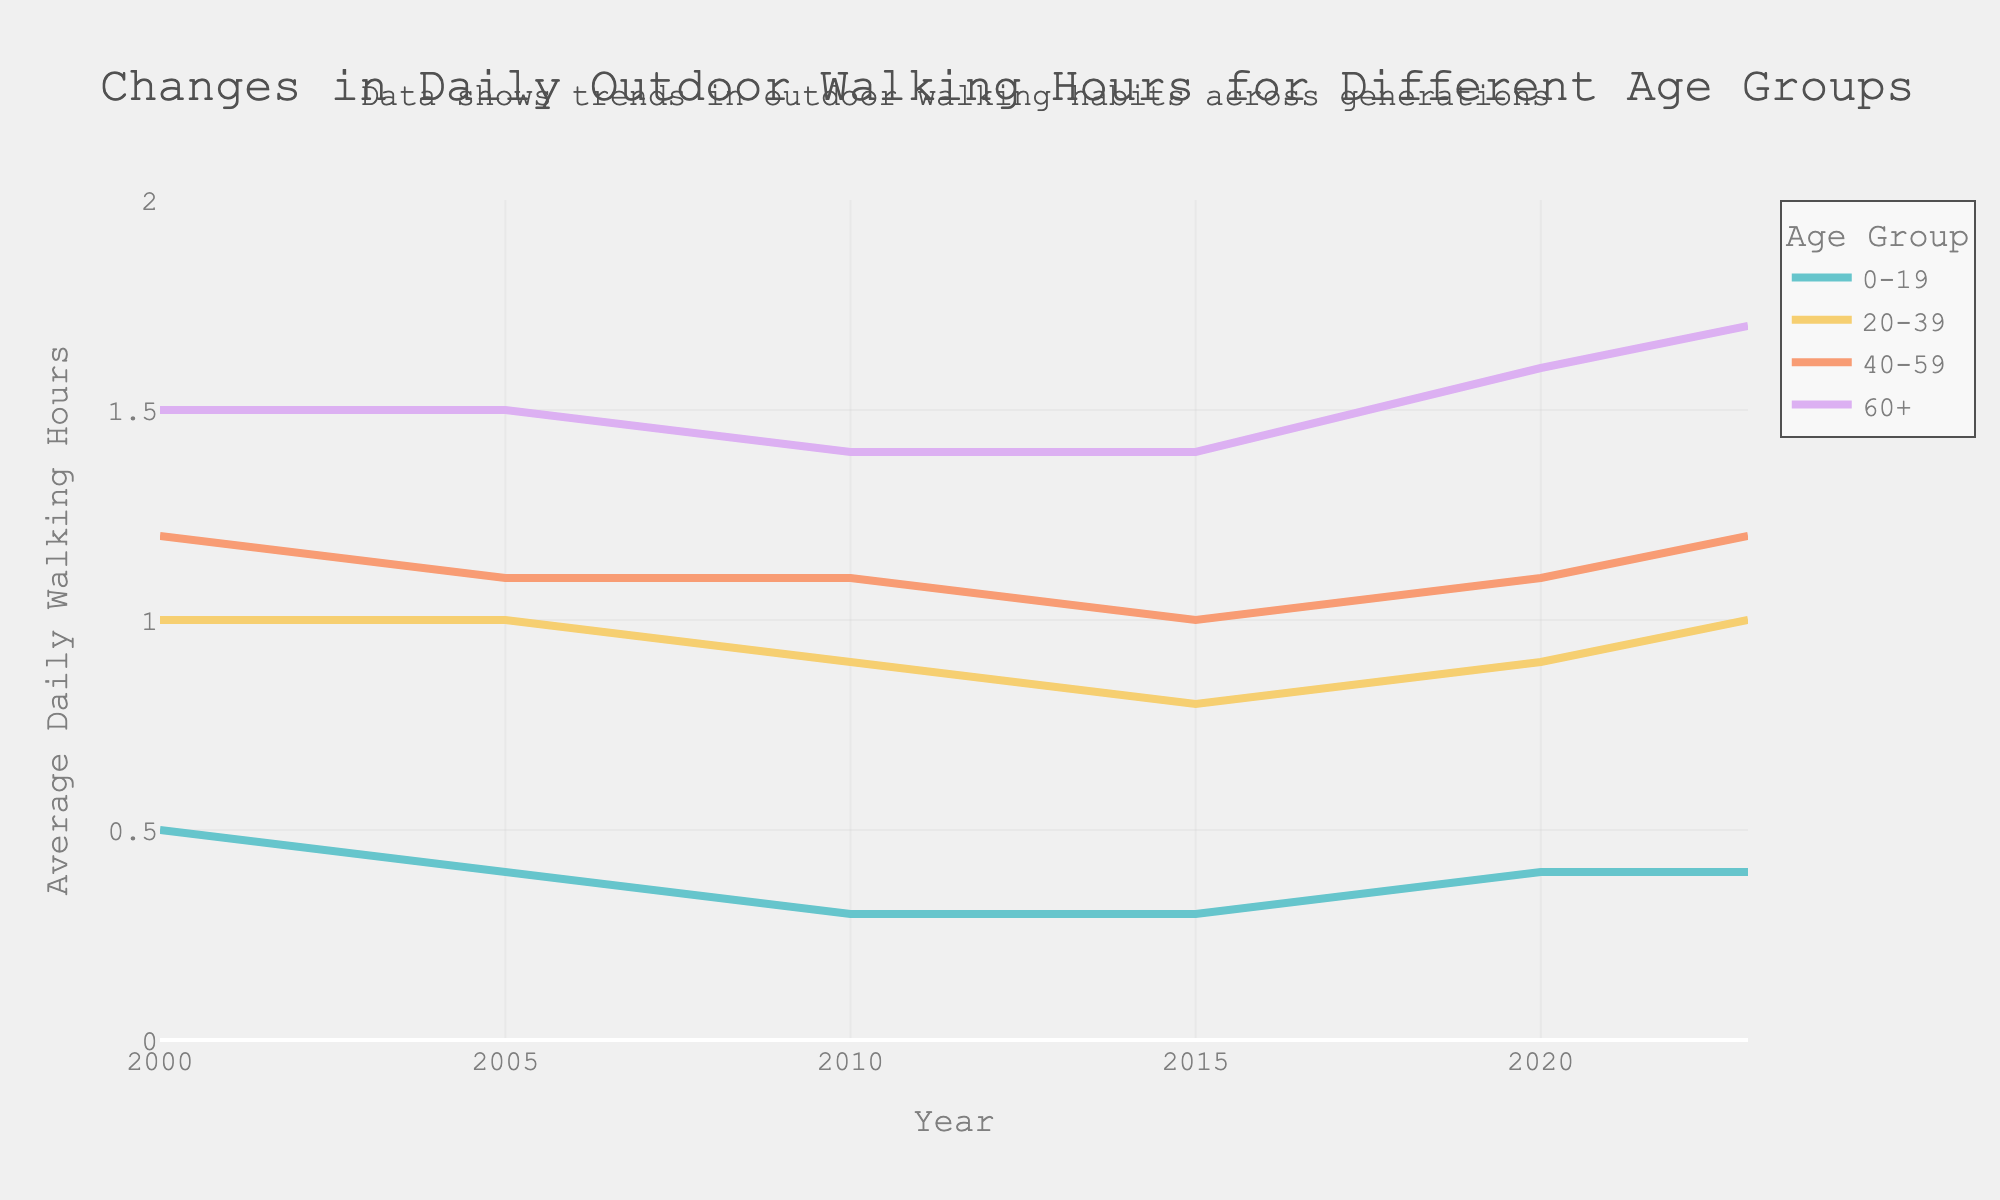what is the title of the plot? The title of the plot is displayed at the top of the figure. It summarizes the subject of the plot in a concise manner.
Answer: Changes in Daily Outdoor Walking Hours for Different Age Groups What is the average daily walking time for the age group 60+ in 2023? Locate the line for the age group "60+" and follow it to the year 2023. The value at that point on the line chart is the answer.
Answer: 1.7 Which age group had the lowest average daily walking hours in 2010? Locate the year 2010 on the x-axis, then find the point with the lowest value among all age groups.
Answer: 0-19 How did the daily walking hours for the age group 20-39 change from 2015 to 2023? Identify the values for the age group 20-39 in the years 2015 and 2023. Calculate the difference between these two values.
Answer: Increased by 0.2 hours What is the trend of daily walking hours for the age group 0-19 over the entire period? Follow the line representing the age group 0-19 from 2000 to 2023. Observe the overall pattern and changes over the years.
Answer: Decreased initially, then increased from 2015 onwards Compare the daily walking hours for age groups 40-59 and 60+ in 2000. Which was higher? Locate the lines for age groups 40-59 and 60+ at the year 2000. Compare the values of these two points to determine which is higher.
Answer: 60+ What is the average value of daily walking hours for the age group 20-39 over the entire period? Sum the daily walking hours for the age group 20-39 across all years and divide by the number of data points (years).
Answer: 0.93 hours Which age group shows the most significant increase in daily walking hours from 2000 to 2023? Measure the difference in daily walking hours between 2000 and 2023 for each age group. The group with the highest difference had the most significant increase.
Answer: 60+ Did the daily walking hours for the age group 40-59 provide a consistent trend over the years? Examine the line for age group 40-59, checking for a consistent increase or decrease across the years without significant fluctuations.
Answer: No, it shows fluctuations 